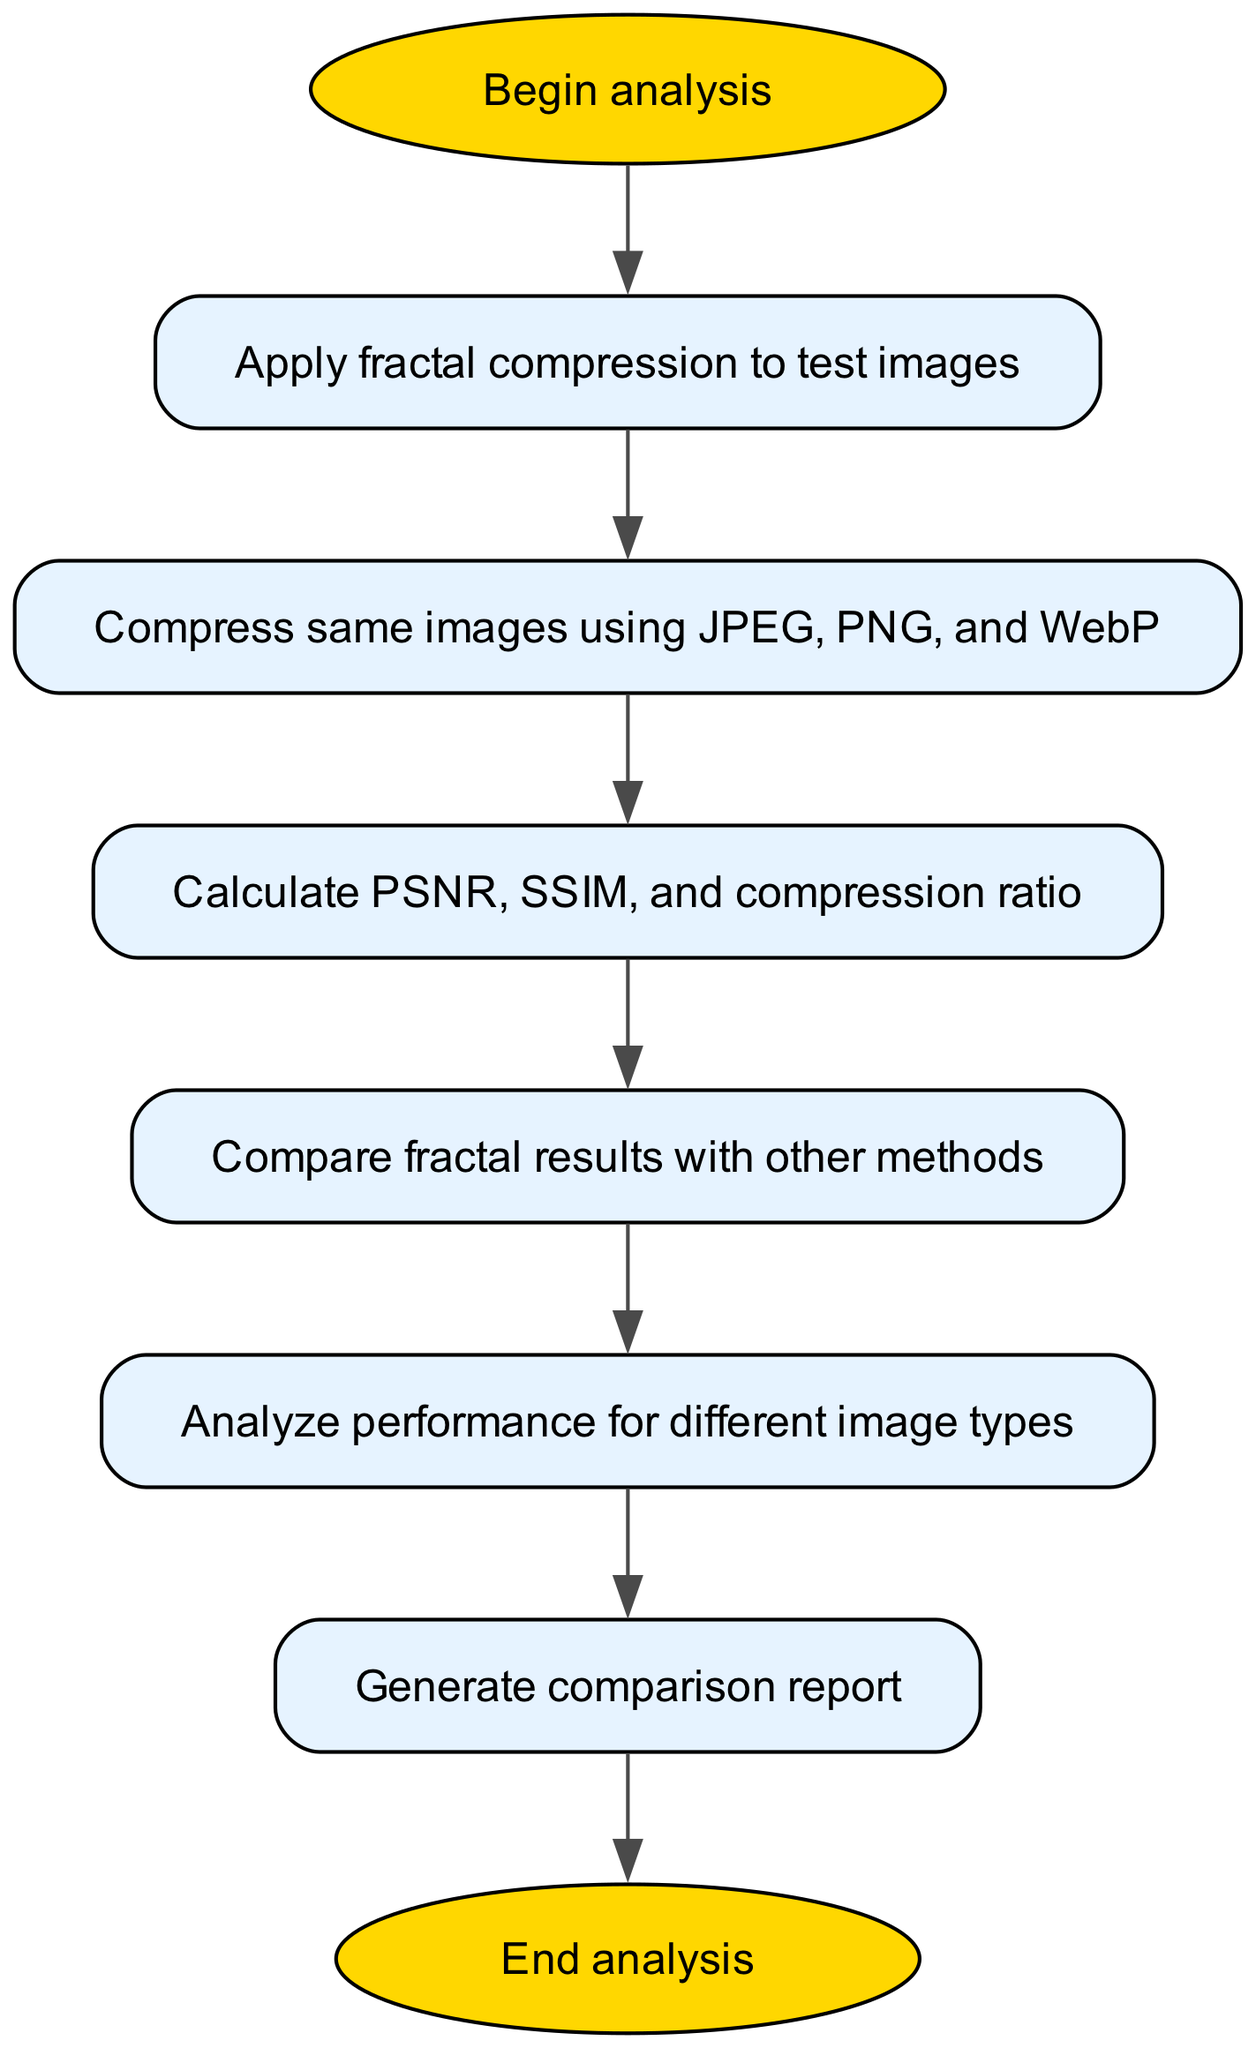What is the first step in the diagram? The diagram starts with the node labeled "Begin analysis." This indicates that the process begins at this step.
Answer: Begin analysis How many nodes are present in the diagram? The diagram has a total of eight nodes, counting all steps from beginning to end.
Answer: Eight What step follows the "Calculate PSNR, SSIM, and compression ratio"? The next step after calculating PSNR, SSIM, and compression ratio is "Compare fractal results with other methods." This can be traced by looking at the connections leading from the metrics node.
Answer: Compare fractal results with other methods Which method of compression comes after applying fractal compression? After applying fractal compression, the next step is to compress the same images using JPEG, PNG, and WebP, as indicated by the direct connection following the fractal compression.
Answer: Compress same images using JPEG, PNG, and WebP What is the final output of the flowchart process? The final output is "End analysis," which signifies the conclusion of the entire process as indicated by the last node in the flowchart.
Answer: End analysis What comparison is made in the analysis process? The analysis process involves comparing fractal results with other compression methods, which is a central aspect of this flowchart.
Answer: Compare fractal results with other methods What is the purpose of the "Generate comparison report" step? This step's purpose is to compile and present the results obtained from the analysis and comparisons done in previous steps, acting as a summary of the findings.
Answer: Generate comparison report Which node is linked directly to the "Analyze performance for different image types"? The "Analyze performance for different image types" node is directly linked from the "Compare fractal results with other methods," indicating that it follows the comparison.
Answer: Compare fractal results with other methods 